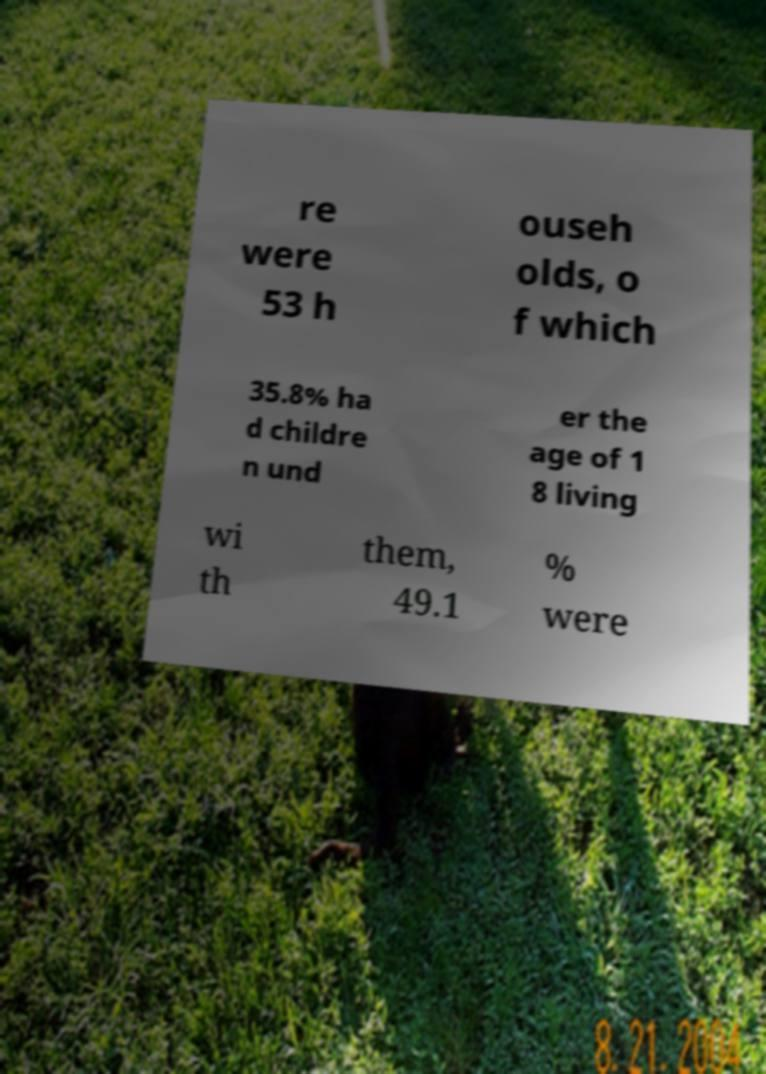Please identify and transcribe the text found in this image. re were 53 h ouseh olds, o f which 35.8% ha d childre n und er the age of 1 8 living wi th them, 49.1 % were 